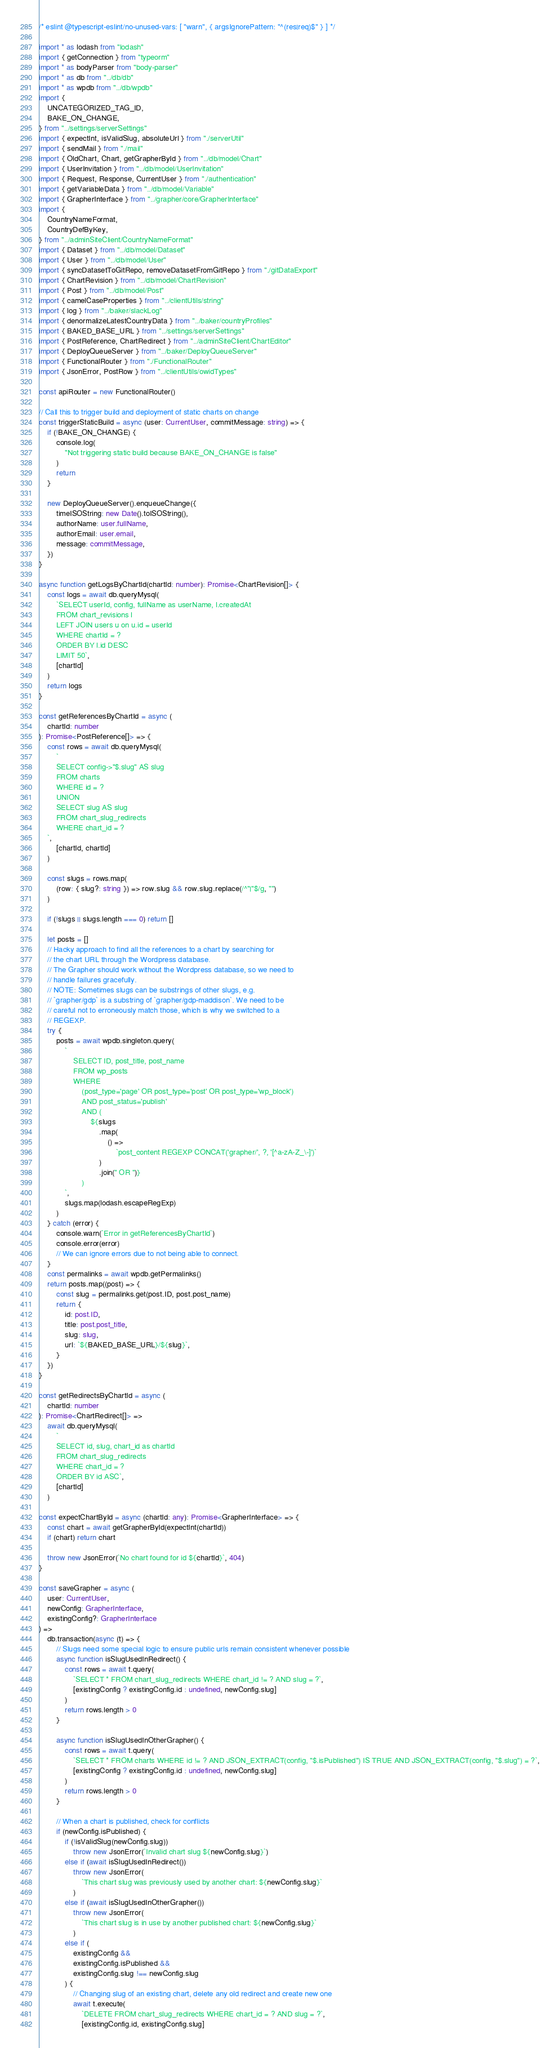Convert code to text. <code><loc_0><loc_0><loc_500><loc_500><_TypeScript_>/* eslint @typescript-eslint/no-unused-vars: [ "warn", { argsIgnorePattern: "^(res|req)$" } ] */

import * as lodash from "lodash"
import { getConnection } from "typeorm"
import * as bodyParser from "body-parser"
import * as db from "../db/db"
import * as wpdb from "../db/wpdb"
import {
    UNCATEGORIZED_TAG_ID,
    BAKE_ON_CHANGE,
} from "../settings/serverSettings"
import { expectInt, isValidSlug, absoluteUrl } from "./serverUtil"
import { sendMail } from "./mail"
import { OldChart, Chart, getGrapherById } from "../db/model/Chart"
import { UserInvitation } from "../db/model/UserInvitation"
import { Request, Response, CurrentUser } from "./authentication"
import { getVariableData } from "../db/model/Variable"
import { GrapherInterface } from "../grapher/core/GrapherInterface"
import {
    CountryNameFormat,
    CountryDefByKey,
} from "../adminSiteClient/CountryNameFormat"
import { Dataset } from "../db/model/Dataset"
import { User } from "../db/model/User"
import { syncDatasetToGitRepo, removeDatasetFromGitRepo } from "./gitDataExport"
import { ChartRevision } from "../db/model/ChartRevision"
import { Post } from "../db/model/Post"
import { camelCaseProperties } from "../clientUtils/string"
import { log } from "../baker/slackLog"
import { denormalizeLatestCountryData } from "../baker/countryProfiles"
import { BAKED_BASE_URL } from "../settings/serverSettings"
import { PostReference, ChartRedirect } from "../adminSiteClient/ChartEditor"
import { DeployQueueServer } from "../baker/DeployQueueServer"
import { FunctionalRouter } from "./FunctionalRouter"
import { JsonError, PostRow } from "../clientUtils/owidTypes"

const apiRouter = new FunctionalRouter()

// Call this to trigger build and deployment of static charts on change
const triggerStaticBuild = async (user: CurrentUser, commitMessage: string) => {
    if (!BAKE_ON_CHANGE) {
        console.log(
            "Not triggering static build because BAKE_ON_CHANGE is false"
        )
        return
    }

    new DeployQueueServer().enqueueChange({
        timeISOString: new Date().toISOString(),
        authorName: user.fullName,
        authorEmail: user.email,
        message: commitMessage,
    })
}

async function getLogsByChartId(chartId: number): Promise<ChartRevision[]> {
    const logs = await db.queryMysql(
        `SELECT userId, config, fullName as userName, l.createdAt
        FROM chart_revisions l
        LEFT JOIN users u on u.id = userId
        WHERE chartId = ?
        ORDER BY l.id DESC
        LIMIT 50`,
        [chartId]
    )
    return logs
}

const getReferencesByChartId = async (
    chartId: number
): Promise<PostReference[]> => {
    const rows = await db.queryMysql(
        `
        SELECT config->"$.slug" AS slug
        FROM charts
        WHERE id = ?
        UNION
        SELECT slug AS slug
        FROM chart_slug_redirects
        WHERE chart_id = ?
    `,
        [chartId, chartId]
    )

    const slugs = rows.map(
        (row: { slug?: string }) => row.slug && row.slug.replace(/^"|"$/g, "")
    )

    if (!slugs || slugs.length === 0) return []

    let posts = []
    // Hacky approach to find all the references to a chart by searching for
    // the chart URL through the Wordpress database.
    // The Grapher should work without the Wordpress database, so we need to
    // handle failures gracefully.
    // NOTE: Sometimes slugs can be substrings of other slugs, e.g.
    // `grapher/gdp` is a substring of `grapher/gdp-maddison`. We need to be
    // careful not to erroneously match those, which is why we switched to a
    // REGEXP.
    try {
        posts = await wpdb.singleton.query(
            `
                SELECT ID, post_title, post_name
                FROM wp_posts
                WHERE
                    (post_type='page' OR post_type='post' OR post_type='wp_block')
                    AND post_status='publish'
                    AND (
                        ${slugs
                            .map(
                                () =>
                                    `post_content REGEXP CONCAT('grapher/', ?, '[^a-zA-Z_\-]')`
                            )
                            .join(" OR ")}
                    )
            `,
            slugs.map(lodash.escapeRegExp)
        )
    } catch (error) {
        console.warn(`Error in getReferencesByChartId`)
        console.error(error)
        // We can ignore errors due to not being able to connect.
    }
    const permalinks = await wpdb.getPermalinks()
    return posts.map((post) => {
        const slug = permalinks.get(post.ID, post.post_name)
        return {
            id: post.ID,
            title: post.post_title,
            slug: slug,
            url: `${BAKED_BASE_URL}/${slug}`,
        }
    })
}

const getRedirectsByChartId = async (
    chartId: number
): Promise<ChartRedirect[]> =>
    await db.queryMysql(
        `
        SELECT id, slug, chart_id as chartId
        FROM chart_slug_redirects
        WHERE chart_id = ?
        ORDER BY id ASC`,
        [chartId]
    )

const expectChartById = async (chartId: any): Promise<GrapherInterface> => {
    const chart = await getGrapherById(expectInt(chartId))
    if (chart) return chart

    throw new JsonError(`No chart found for id ${chartId}`, 404)
}

const saveGrapher = async (
    user: CurrentUser,
    newConfig: GrapherInterface,
    existingConfig?: GrapherInterface
) =>
    db.transaction(async (t) => {
        // Slugs need some special logic to ensure public urls remain consistent whenever possible
        async function isSlugUsedInRedirect() {
            const rows = await t.query(
                `SELECT * FROM chart_slug_redirects WHERE chart_id != ? AND slug = ?`,
                [existingConfig ? existingConfig.id : undefined, newConfig.slug]
            )
            return rows.length > 0
        }

        async function isSlugUsedInOtherGrapher() {
            const rows = await t.query(
                `SELECT * FROM charts WHERE id != ? AND JSON_EXTRACT(config, "$.isPublished") IS TRUE AND JSON_EXTRACT(config, "$.slug") = ?`,
                [existingConfig ? existingConfig.id : undefined, newConfig.slug]
            )
            return rows.length > 0
        }

        // When a chart is published, check for conflicts
        if (newConfig.isPublished) {
            if (!isValidSlug(newConfig.slug))
                throw new JsonError(`Invalid chart slug ${newConfig.slug}`)
            else if (await isSlugUsedInRedirect())
                throw new JsonError(
                    `This chart slug was previously used by another chart: ${newConfig.slug}`
                )
            else if (await isSlugUsedInOtherGrapher())
                throw new JsonError(
                    `This chart slug is in use by another published chart: ${newConfig.slug}`
                )
            else if (
                existingConfig &&
                existingConfig.isPublished &&
                existingConfig.slug !== newConfig.slug
            ) {
                // Changing slug of an existing chart, delete any old redirect and create new one
                await t.execute(
                    `DELETE FROM chart_slug_redirects WHERE chart_id = ? AND slug = ?`,
                    [existingConfig.id, existingConfig.slug]</code> 